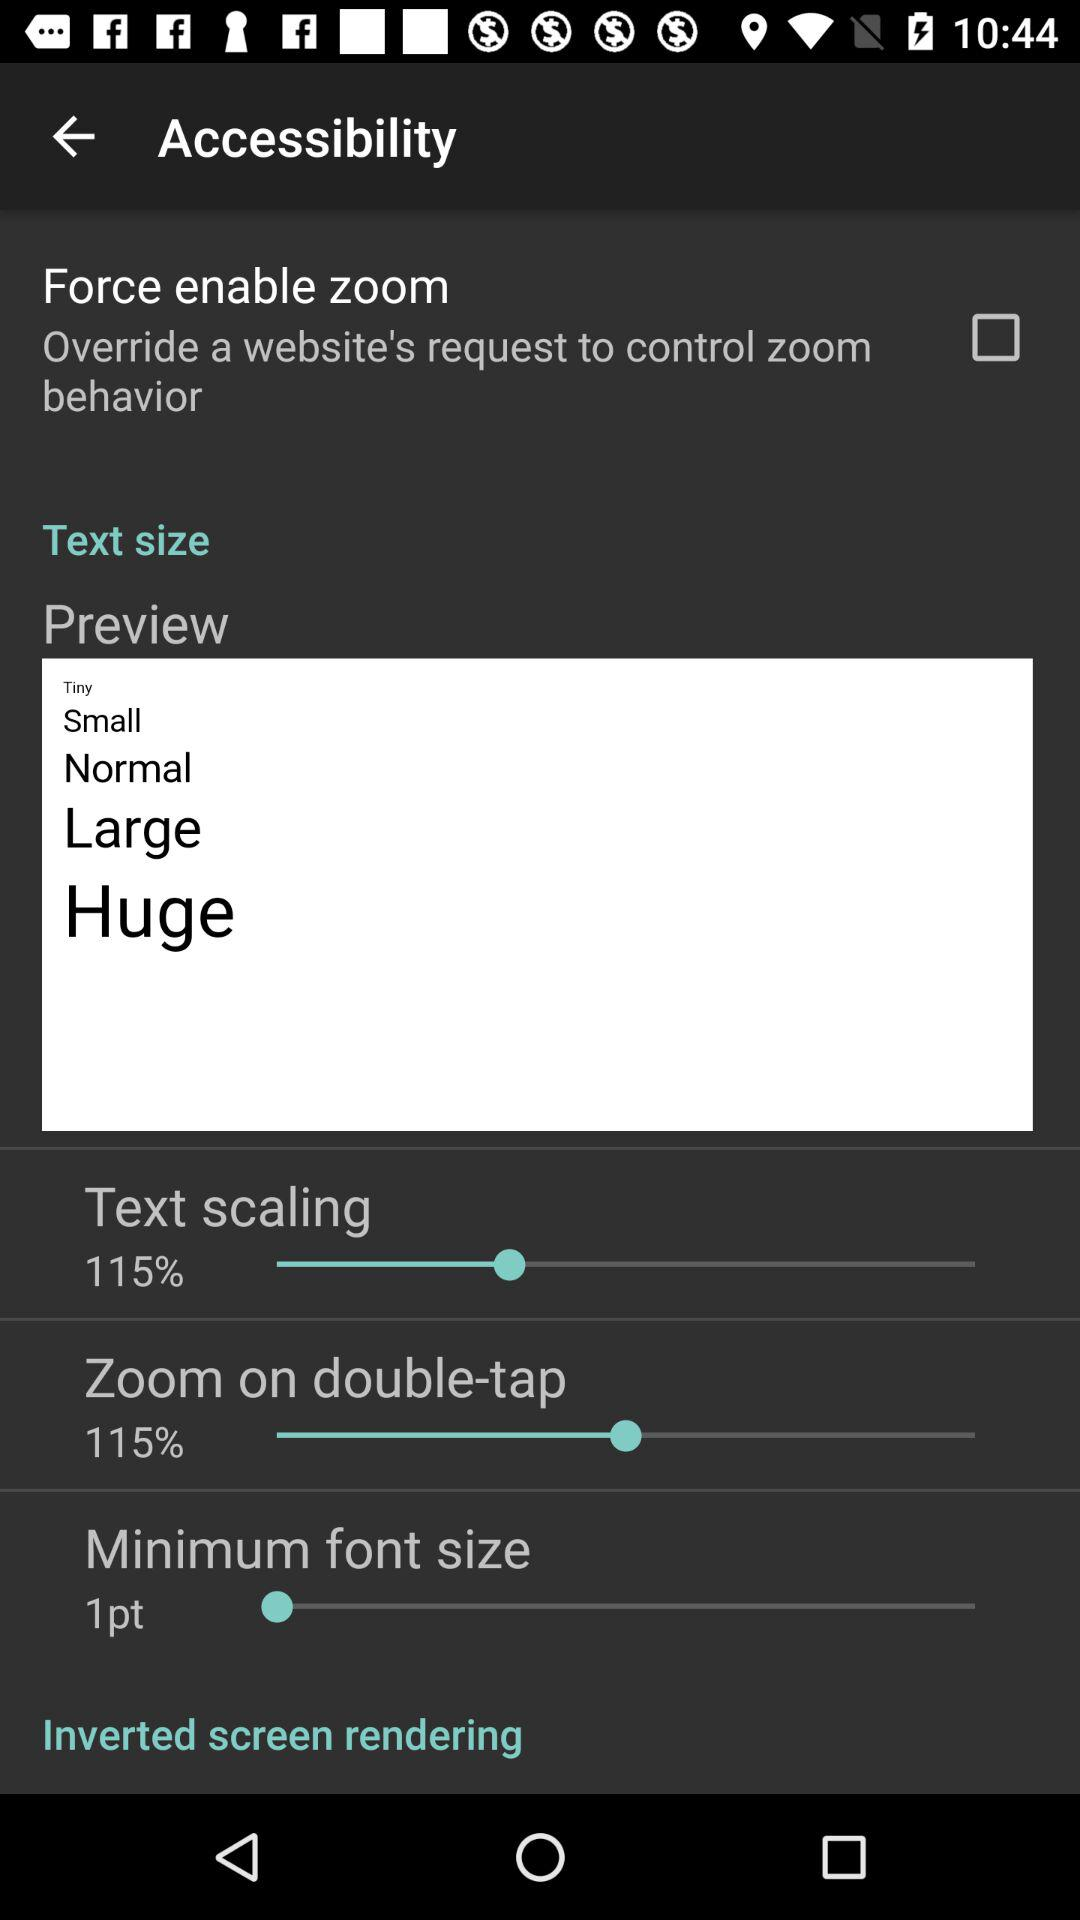How many items can be found in the 'Text size' section?
Answer the question using a single word or phrase. 5 